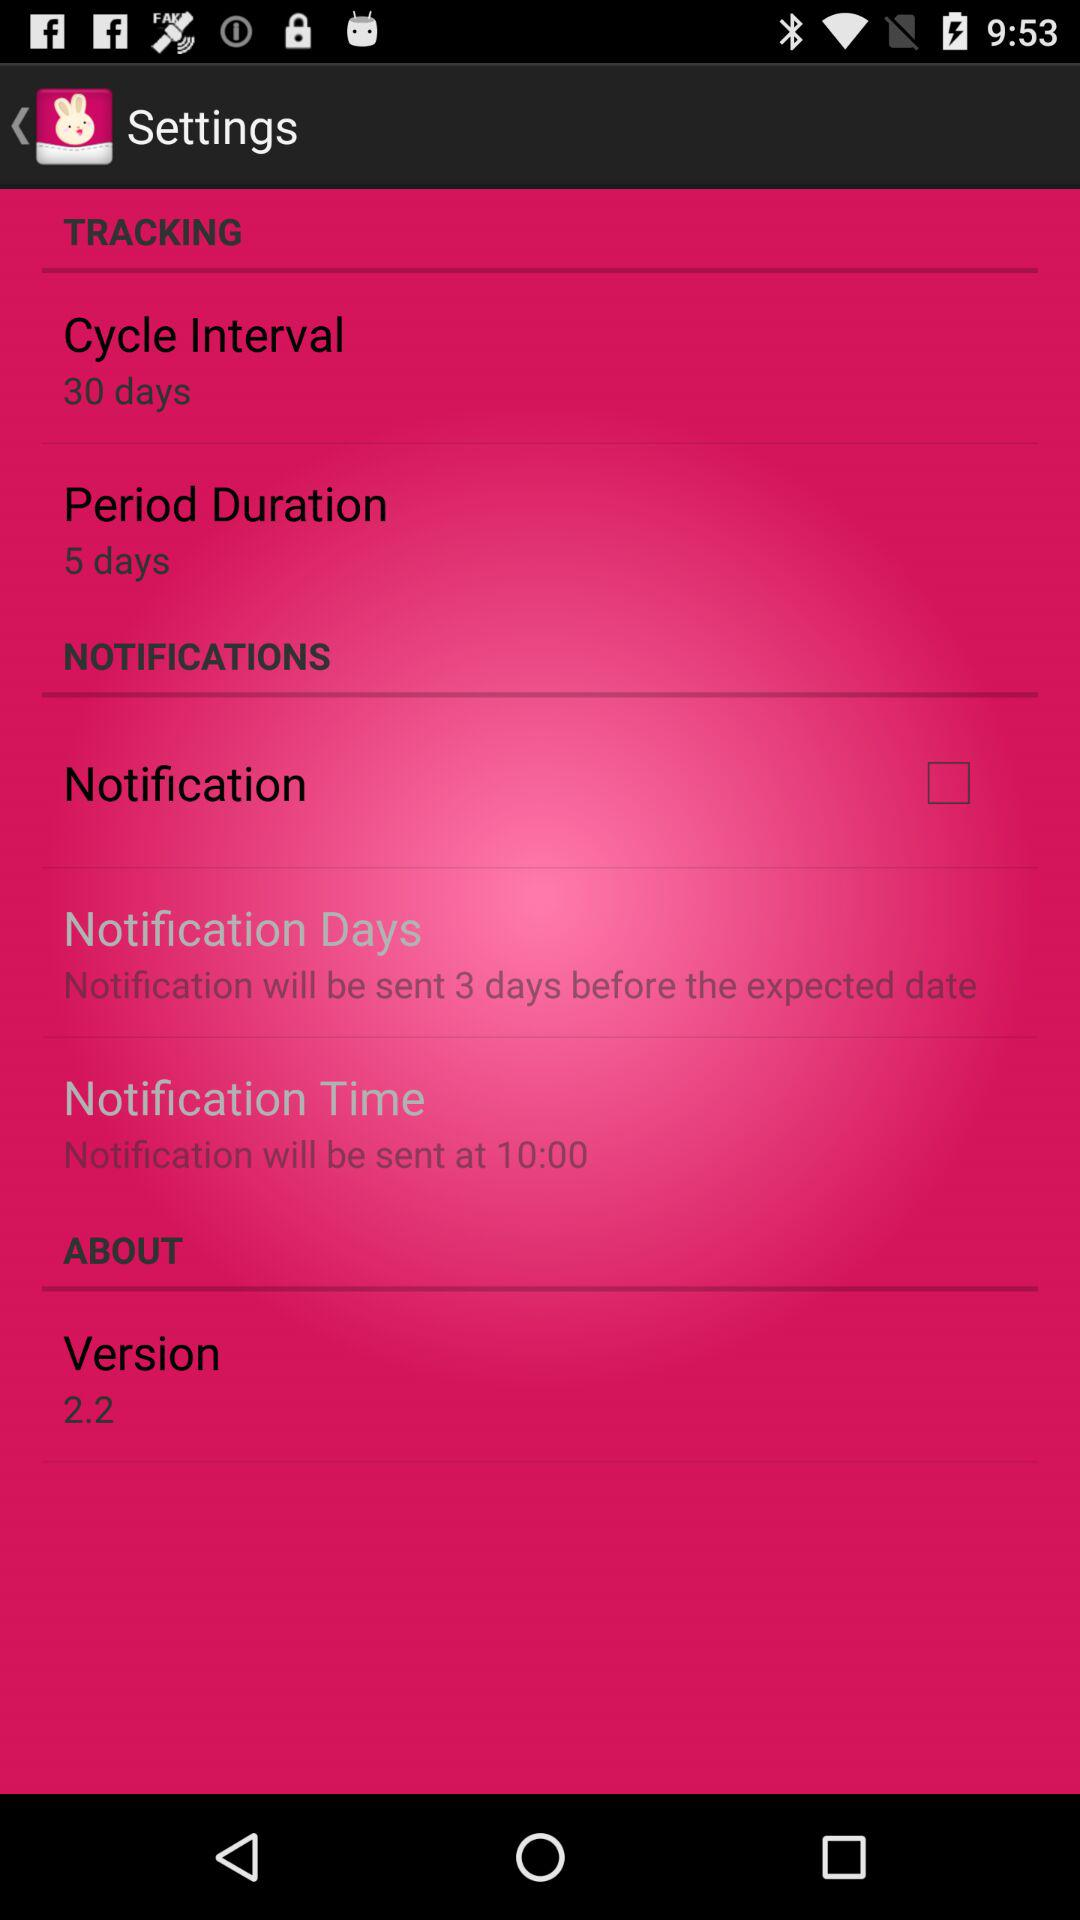How many days is the notification sent before the expected date?
Answer the question using a single word or phrase. 3 days 